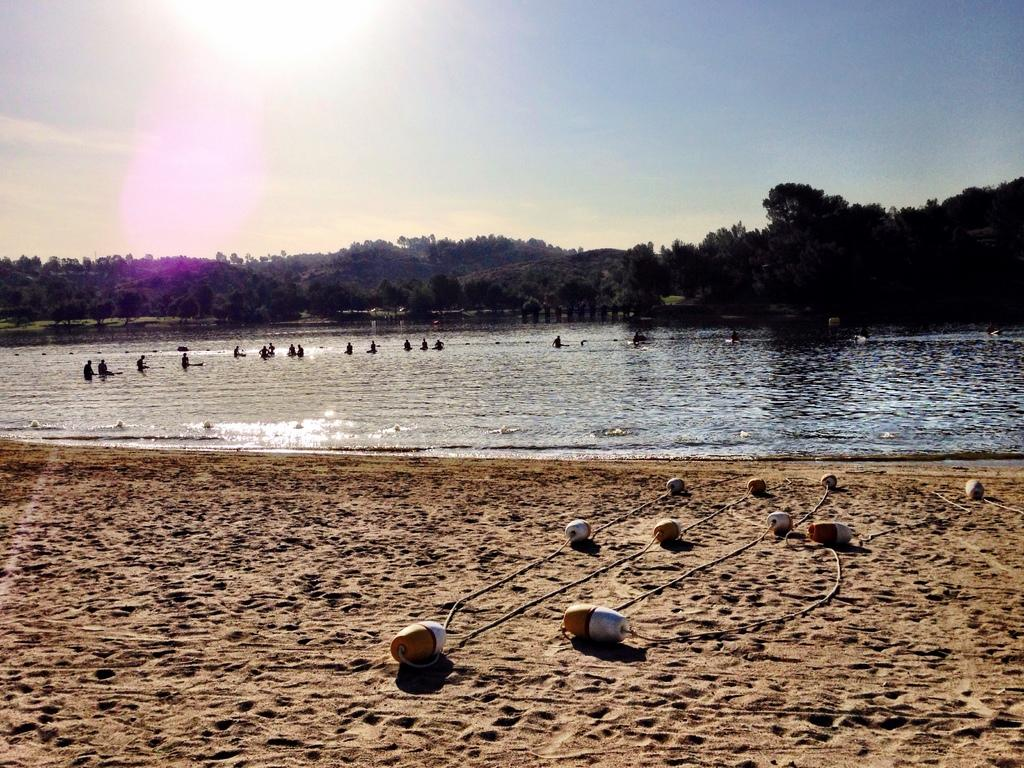What is on the sand in the image? There are objects on the sand in the image. What are the people in the image doing? There is a group of people in the water in the image. What type of vegetation can be seen in the image? There are trees visible in the image. What is visible in the background of the image? The sky is visible in the background of the image. What type of comb can be seen in the image? There is no comb present in the image. What kind of feast is being prepared on the sand? There is no feast being prepared in the image; it features objects on the sand and people in the water. 